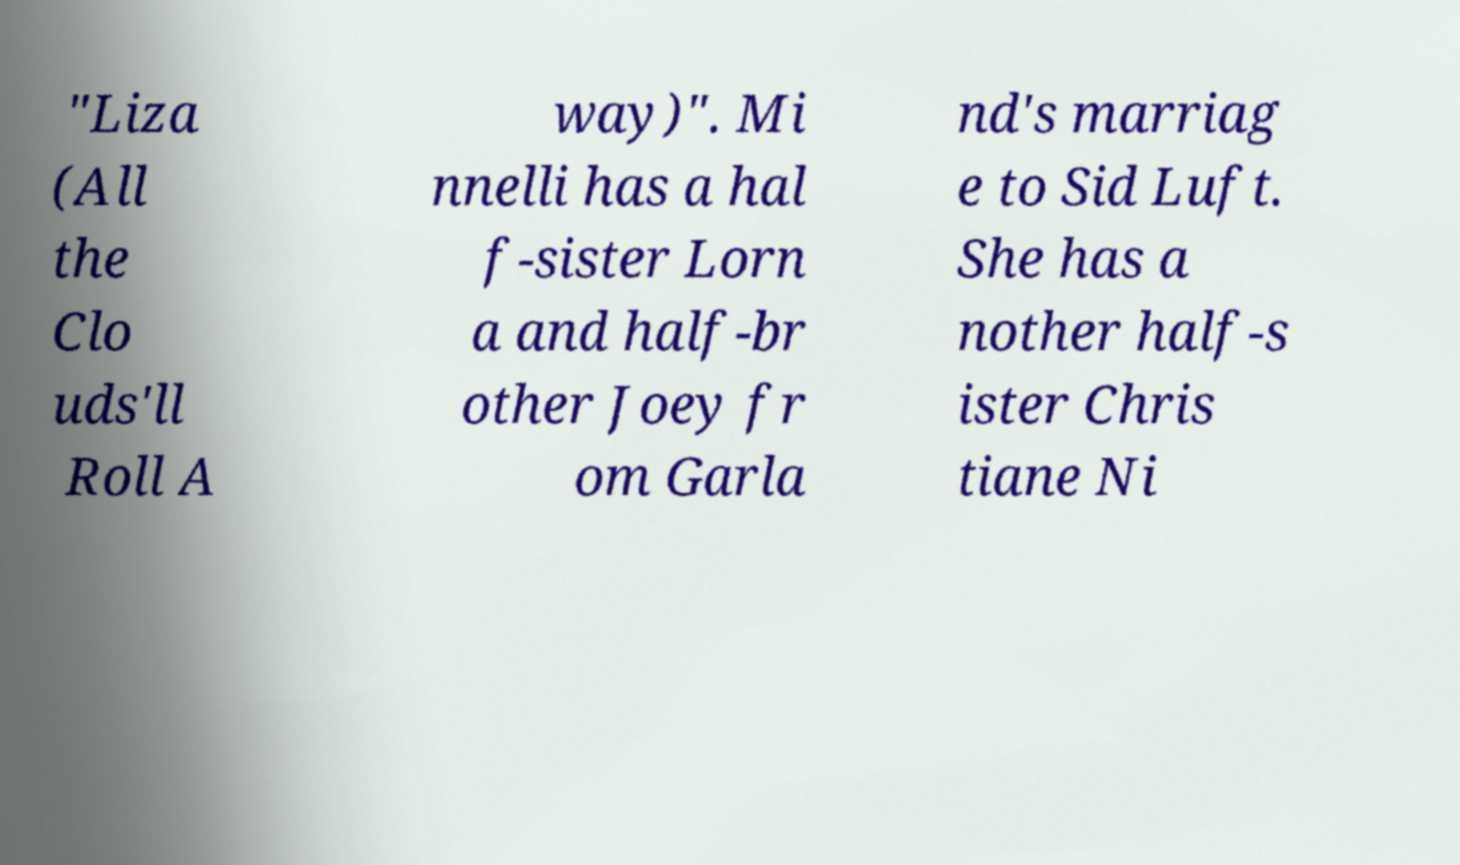I need the written content from this picture converted into text. Can you do that? "Liza (All the Clo uds'll Roll A way)". Mi nnelli has a hal f-sister Lorn a and half-br other Joey fr om Garla nd's marriag e to Sid Luft. She has a nother half-s ister Chris tiane Ni 